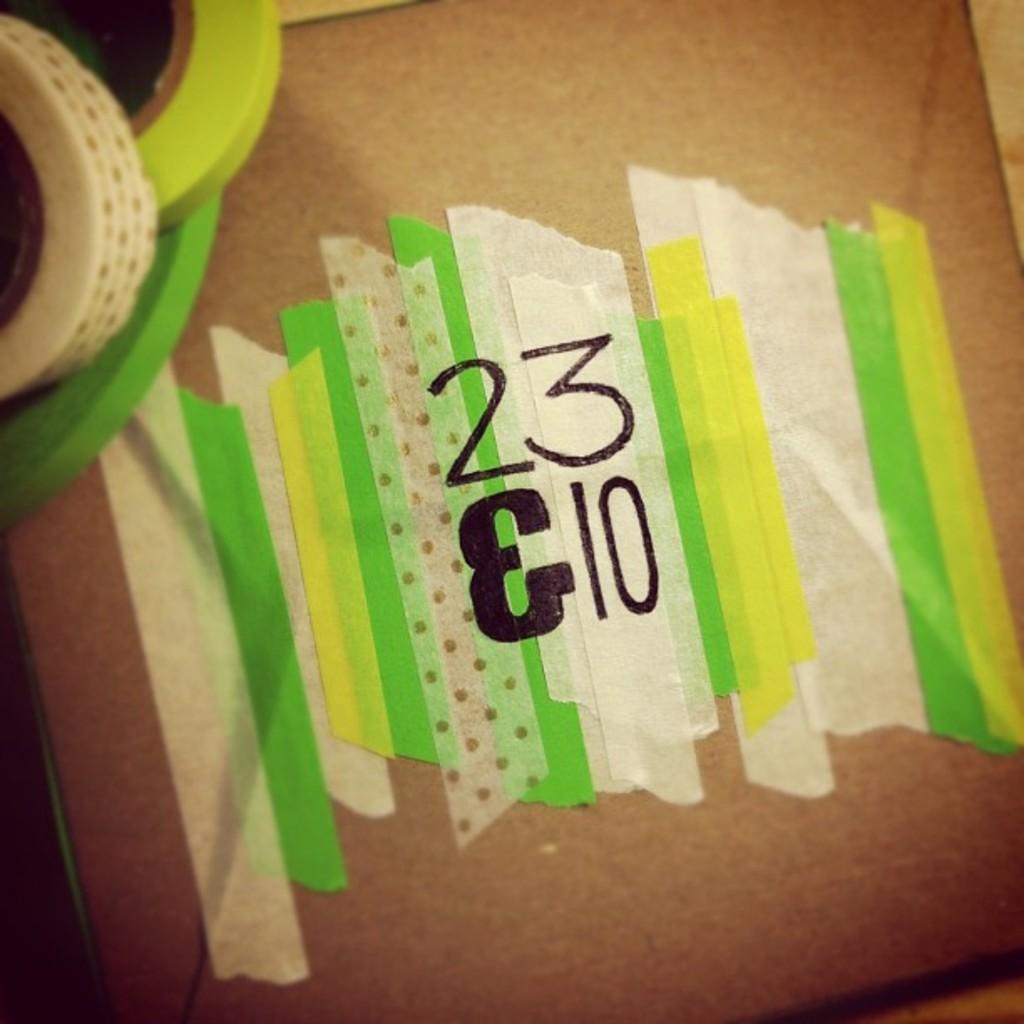How would you summarize this image in a sentence or two? In this image there is a board having few papers attached to it. On papers there is some text written. Left top there are few tapes on the board. 